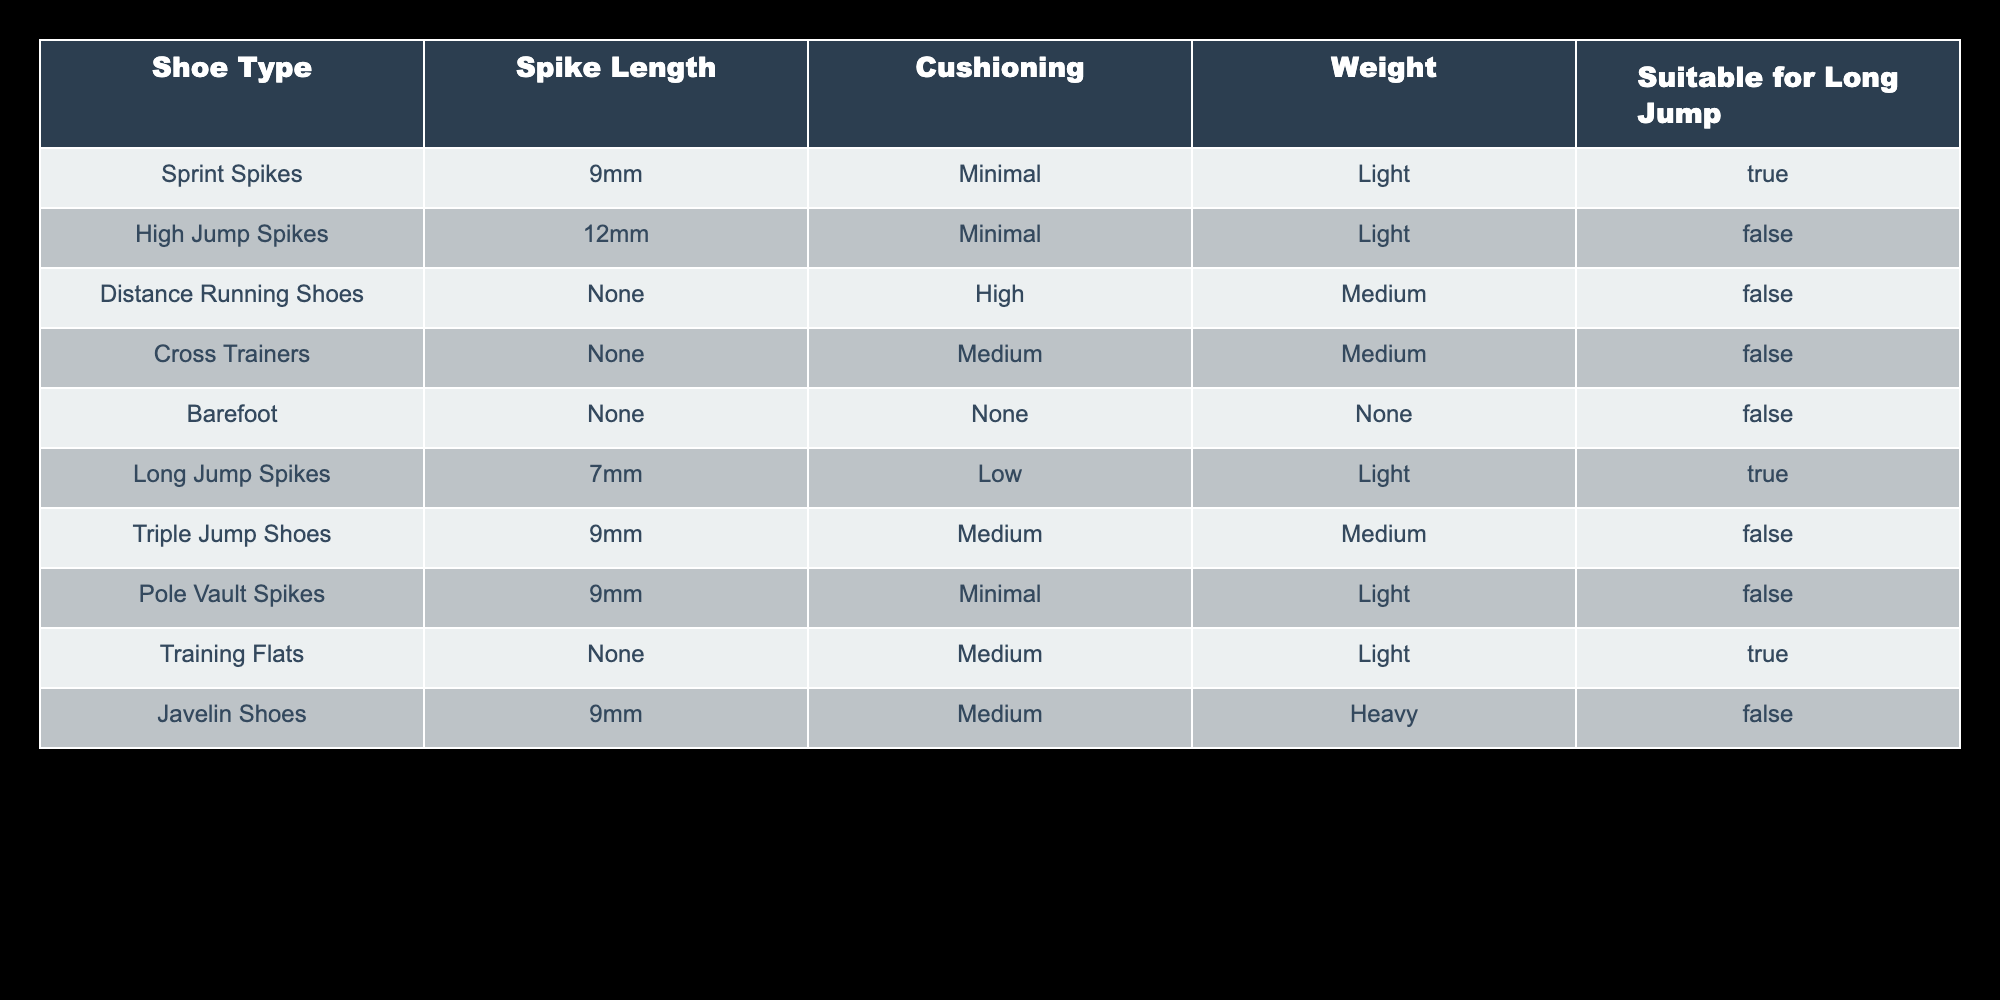What type of footwear is suitable for long jump? By examining the "Suitable for Long Jump" column, we can see that "Sprint Spikes," "Long Jump Spikes," and "Training Flats" are the types marked as true.
Answer: Sprint Spikes, Long Jump Spikes, Training Flats What is the maximum spike length found in the table? The table lists spike lengths of 9mm, 12mm, and 7mm. Among these, 12mm is the maximum value.
Answer: 12mm How many shoe types are suggested for long jump? From the "Suitable for Long Jump" column, there are three shoe types that are marked true, which indicates their suitability for long jump events.
Answer: 3 Are "Distance Running Shoes" suitable for long jump? Looking at the "Suitable for Long Jump" column, "Distance Running Shoes" is marked as false, indicating they are not suitable.
Answer: No What is the average spike length of suitable shoes for long jump? For the suitable shoes, we have spike lengths of 9mm (Sprint Spikes), 7mm (Long Jump Spikes), and none for Training Flats. Thus, we calculate the average as follows: (9 + 7) / 2 = 8mm, since Training Flats have no spike length.
Answer: 8mm Which shoe type has the lowest cushioning? Checking the "Cushioning" column, "Long Jump Spikes" has "Low" cushioning, followed by "Sprint Spikes" and "High Jump Spikes," which have "Minimal." So, "Long Jump Spikes" has the lowest cushioning.
Answer: Long Jump Spikes Is "Triple Jump Shoes" suitable for long jump? By referencing the "Suitable for Long Jump" column, "Triple Jump Shoes" is marked false, indicating it is not suitable for long jump.
Answer: No What is the total weight of all the shoes considered suitable for long jump? The suitable shoes for long jump are "Sprint Spikes," "Long Jump Spikes," and "Training Flats." Their respective weights are "Light," "Light," and "Light." Since all are "Light," we can infer that the total weight remains consistent with the term "Light."
Answer: Light 